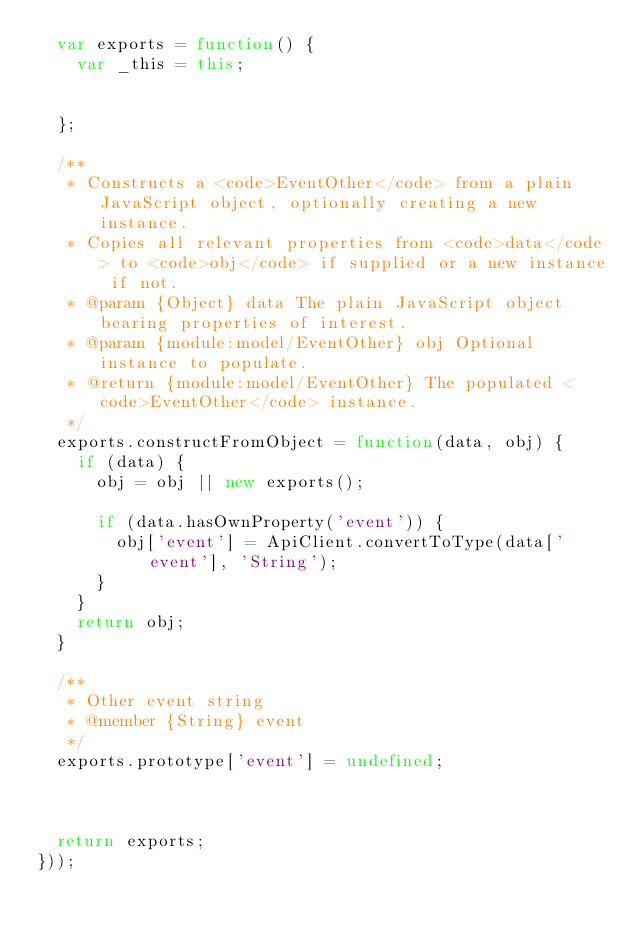<code> <loc_0><loc_0><loc_500><loc_500><_JavaScript_>  var exports = function() {
    var _this = this;


  };

  /**
   * Constructs a <code>EventOther</code> from a plain JavaScript object, optionally creating a new instance.
   * Copies all relevant properties from <code>data</code> to <code>obj</code> if supplied or a new instance if not.
   * @param {Object} data The plain JavaScript object bearing properties of interest.
   * @param {module:model/EventOther} obj Optional instance to populate.
   * @return {module:model/EventOther} The populated <code>EventOther</code> instance.
   */
  exports.constructFromObject = function(data, obj) {
    if (data) {
      obj = obj || new exports();

      if (data.hasOwnProperty('event')) {
        obj['event'] = ApiClient.convertToType(data['event'], 'String');
      }
    }
    return obj;
  }

  /**
   * Other event string
   * @member {String} event
   */
  exports.prototype['event'] = undefined;



  return exports;
}));


</code> 